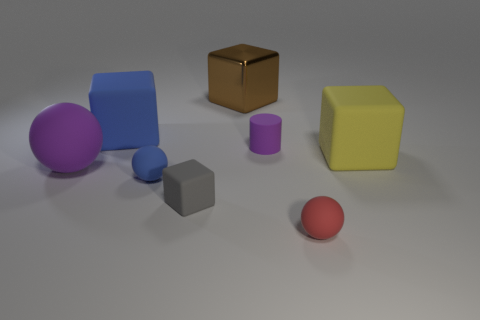Subtract 1 blocks. How many blocks are left? 3 Add 1 large purple shiny balls. How many objects exist? 9 Subtract all cylinders. How many objects are left? 7 Add 7 blue matte blocks. How many blue matte blocks exist? 8 Subtract 0 purple blocks. How many objects are left? 8 Subtract all yellow matte things. Subtract all small cylinders. How many objects are left? 6 Add 1 small gray blocks. How many small gray blocks are left? 2 